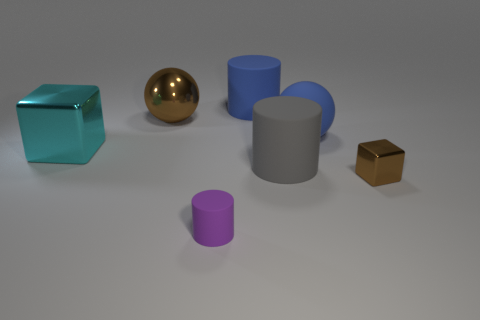Is the shiny sphere the same color as the tiny metal object?
Offer a very short reply. Yes. How many other large matte balls have the same color as the large matte ball?
Make the answer very short. 0. How many matte balls are there?
Make the answer very short. 1. How many tiny purple things have the same material as the small brown cube?
Keep it short and to the point. 0. There is a brown metallic thing that is the same shape as the cyan metallic object; what size is it?
Provide a short and direct response. Small. What material is the gray cylinder?
Provide a short and direct response. Rubber. What material is the tiny thing to the right of the blue rubber cylinder to the right of the brown metallic thing left of the tiny purple cylinder?
Provide a short and direct response. Metal. There is a tiny metallic object that is the same shape as the large cyan shiny object; what color is it?
Keep it short and to the point. Brown. There is a matte cylinder behind the large gray cylinder; is it the same color as the ball that is to the right of the purple matte thing?
Make the answer very short. Yes. Are there more cylinders that are behind the large blue matte sphere than large red balls?
Ensure brevity in your answer.  Yes. 